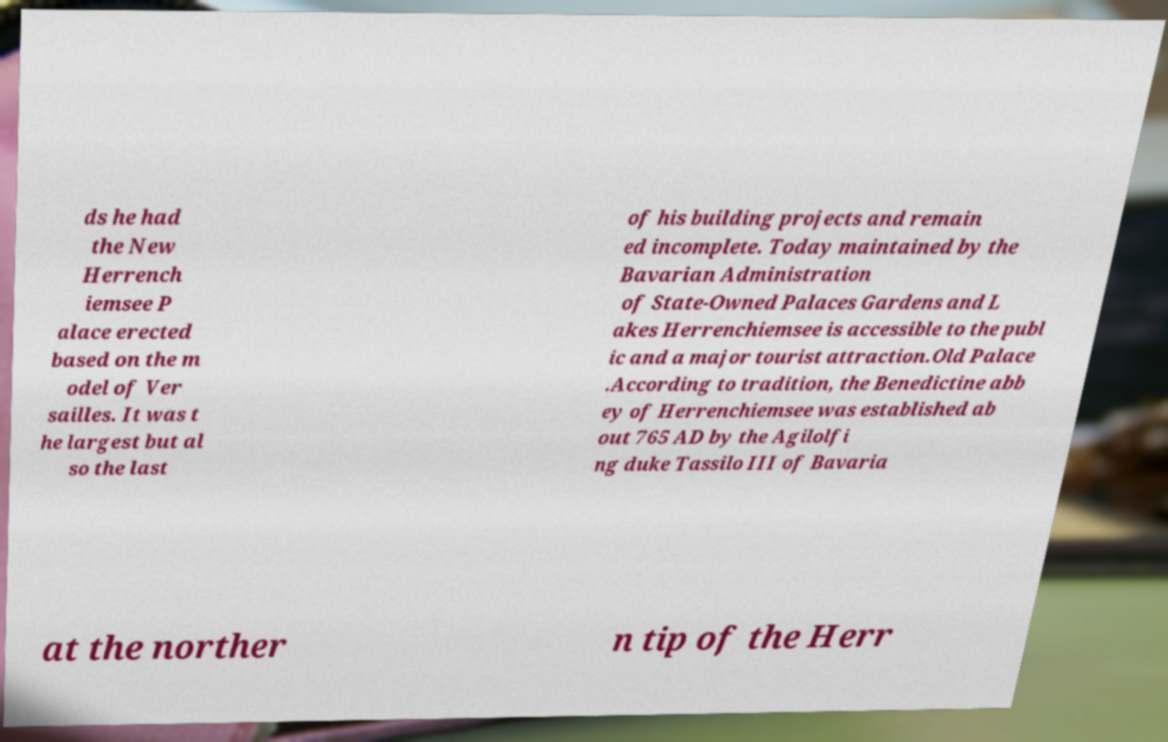For documentation purposes, I need the text within this image transcribed. Could you provide that? ds he had the New Herrench iemsee P alace erected based on the m odel of Ver sailles. It was t he largest but al so the last of his building projects and remain ed incomplete. Today maintained by the Bavarian Administration of State-Owned Palaces Gardens and L akes Herrenchiemsee is accessible to the publ ic and a major tourist attraction.Old Palace .According to tradition, the Benedictine abb ey of Herrenchiemsee was established ab out 765 AD by the Agilolfi ng duke Tassilo III of Bavaria at the norther n tip of the Herr 